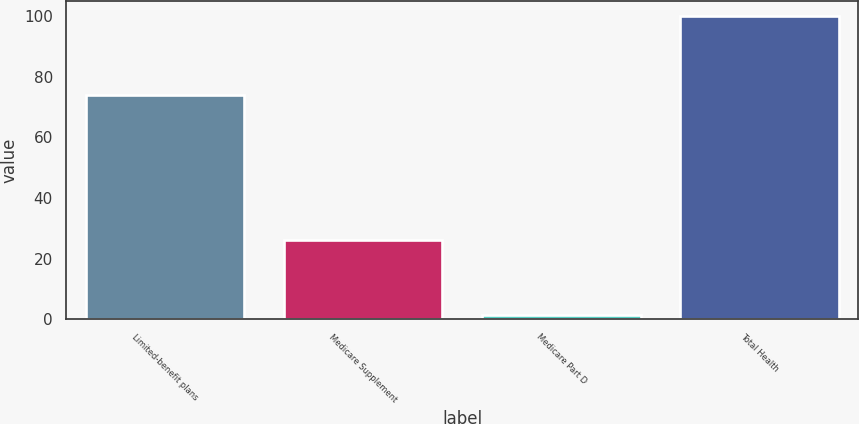<chart> <loc_0><loc_0><loc_500><loc_500><bar_chart><fcel>Limited-benefit plans<fcel>Medicare Supplement<fcel>Medicare Part D<fcel>Total Health<nl><fcel>74<fcel>26<fcel>1.43<fcel>100<nl></chart> 